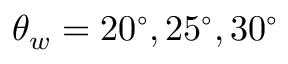<formula> <loc_0><loc_0><loc_500><loc_500>\theta _ { w } = 2 0 ^ { \circ } , 2 5 ^ { \circ } , 3 0 ^ { \circ }</formula> 